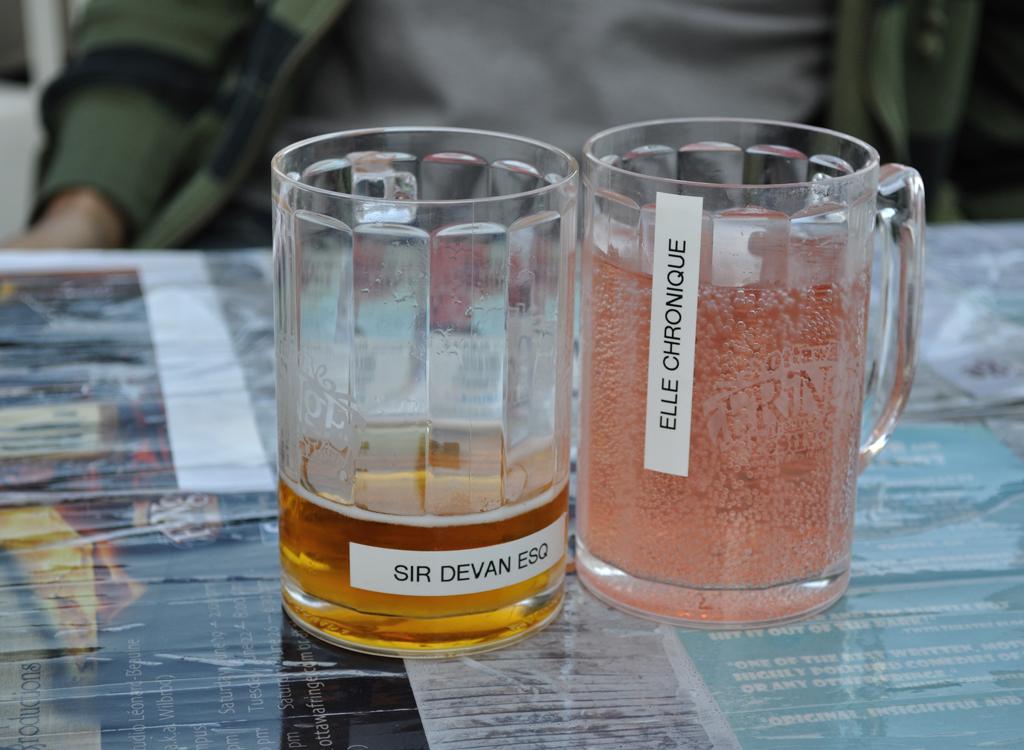What does the cup on the left say?
Your answer should be compact. Sir devan esq. What does the cup on the right say?
Your answer should be very brief. Elle chronique. 